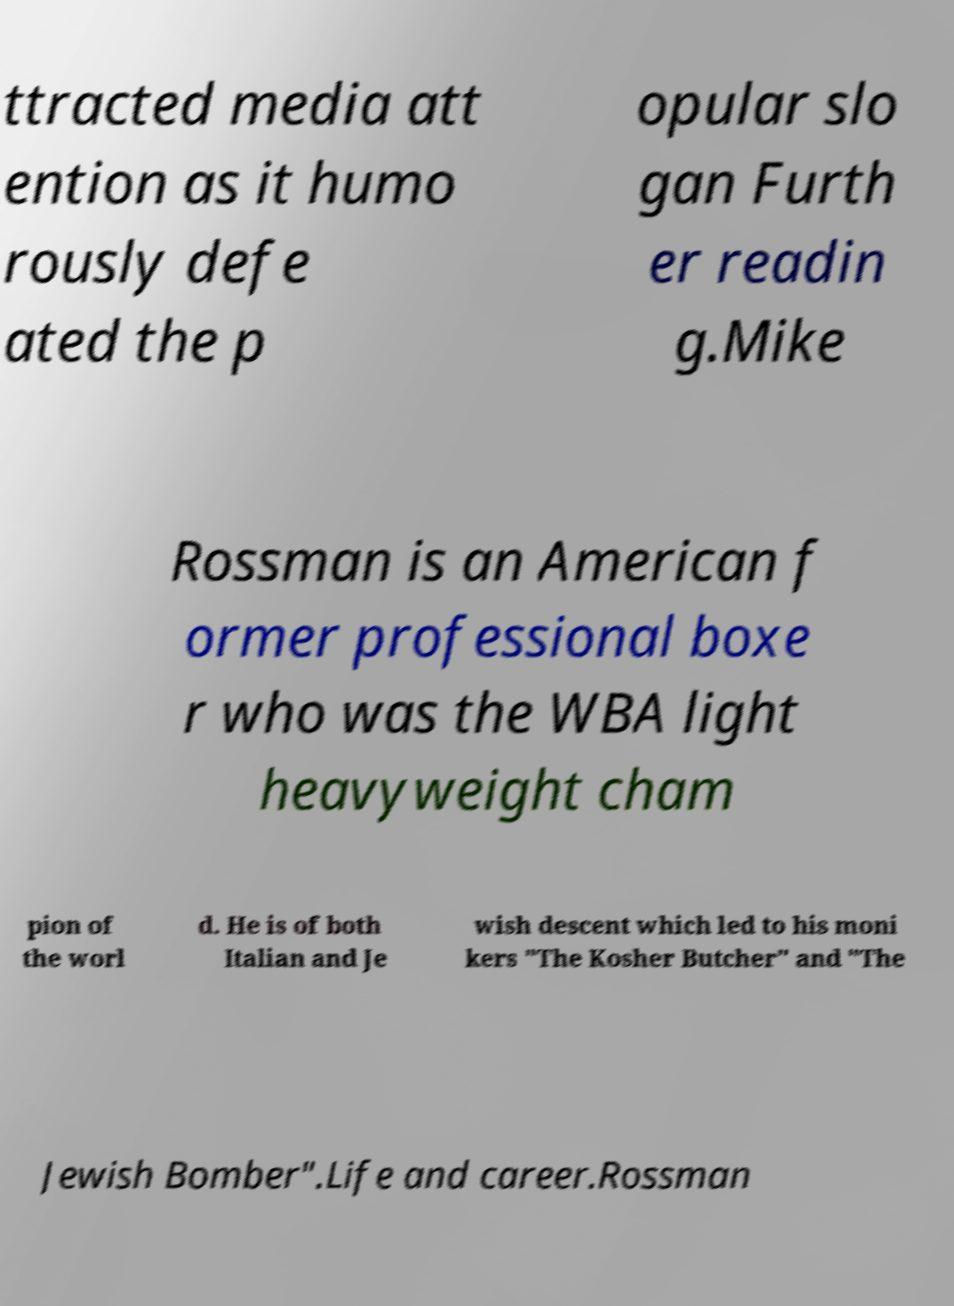Please read and relay the text visible in this image. What does it say? ttracted media att ention as it humo rously defe ated the p opular slo gan Furth er readin g.Mike Rossman is an American f ormer professional boxe r who was the WBA light heavyweight cham pion of the worl d. He is of both Italian and Je wish descent which led to his moni kers "The Kosher Butcher" and "The Jewish Bomber".Life and career.Rossman 